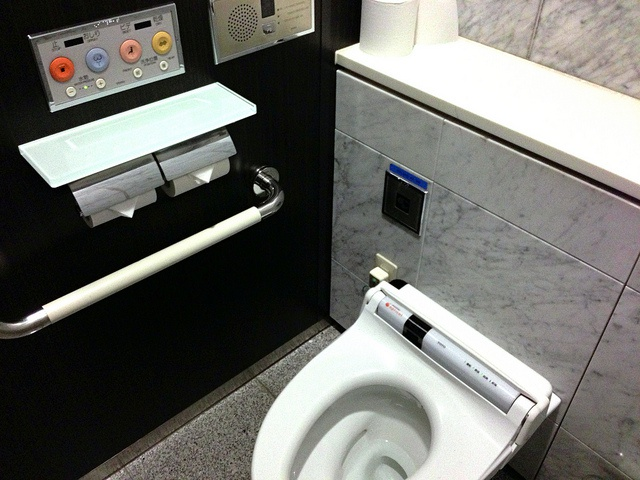Describe the objects in this image and their specific colors. I can see a toilet in black, white, darkgray, gray, and lightgray tones in this image. 